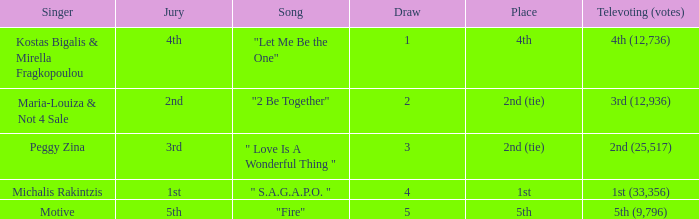Kostas Bigalis & Mirella Fragkopoulou the singer had what has the jury? 4th. 